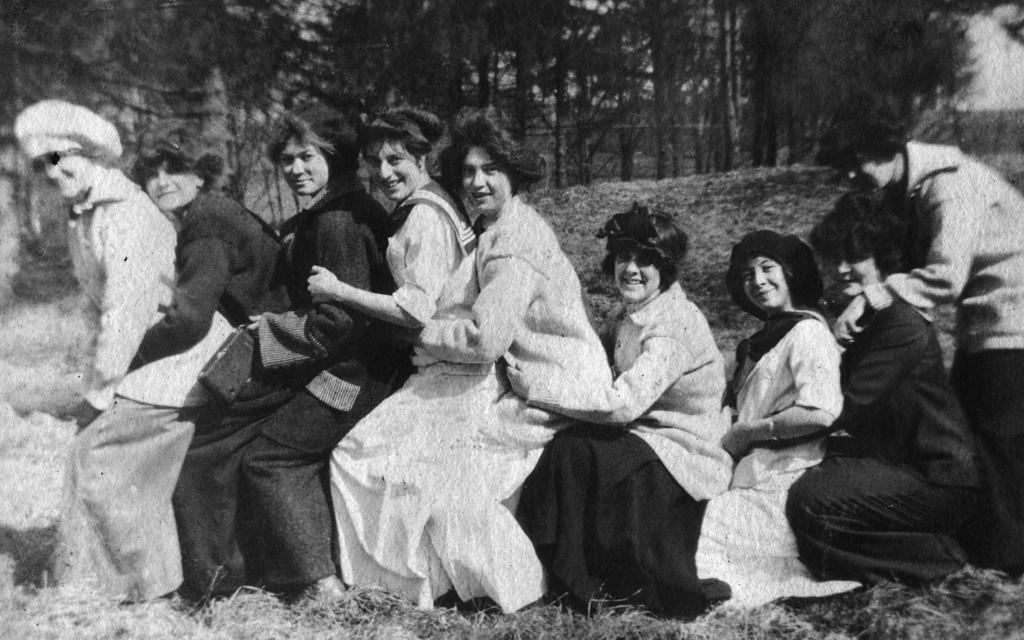Could you give a brief overview of what you see in this image? This is a black and white image, in this image in the center there are some people. And at the bottom there is grass, and in the background there are trees and grass. 